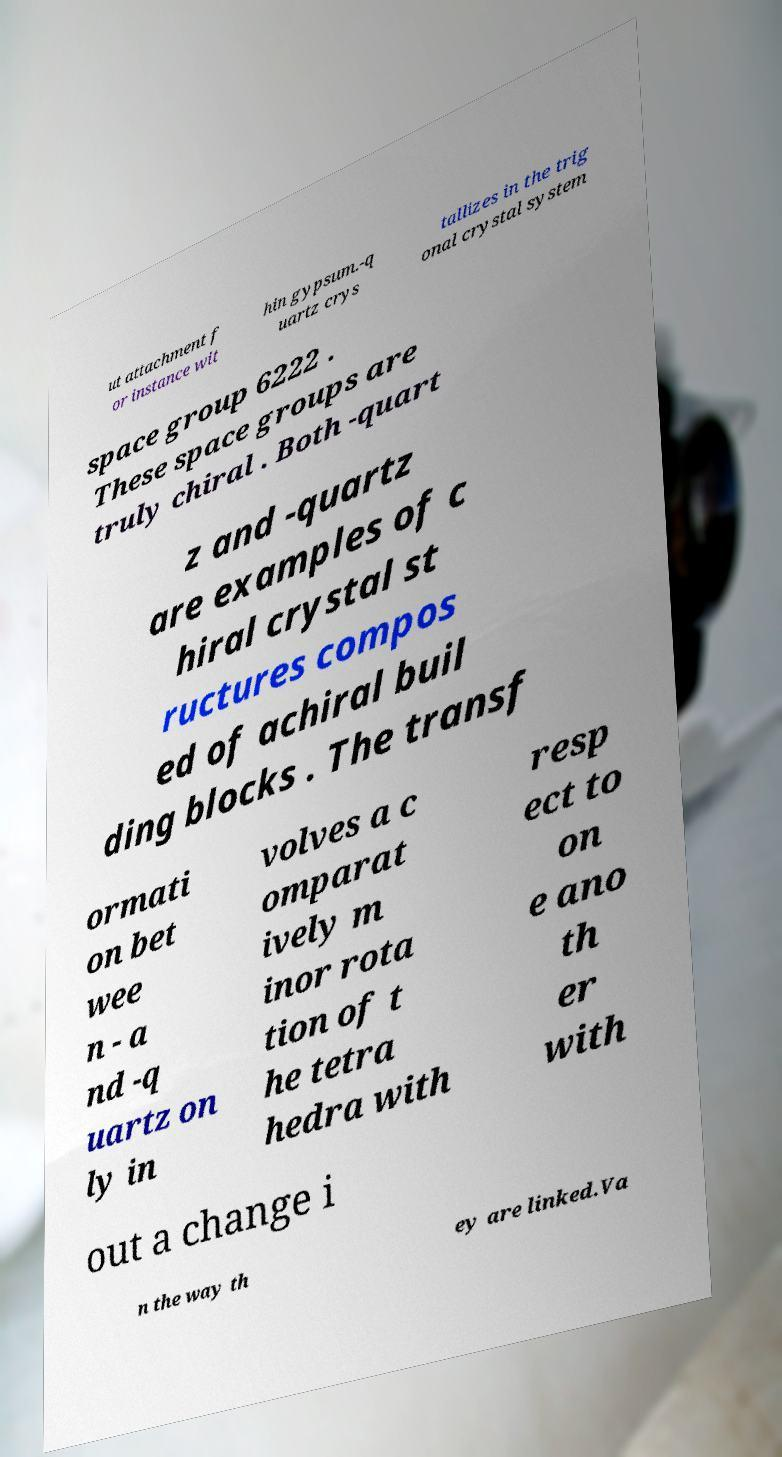What messages or text are displayed in this image? I need them in a readable, typed format. ut attachment f or instance wit hin gypsum.-q uartz crys tallizes in the trig onal crystal system space group 6222 . These space groups are truly chiral . Both -quart z and -quartz are examples of c hiral crystal st ructures compos ed of achiral buil ding blocks . The transf ormati on bet wee n - a nd -q uartz on ly in volves a c omparat ively m inor rota tion of t he tetra hedra with resp ect to on e ano th er with out a change i n the way th ey are linked.Va 